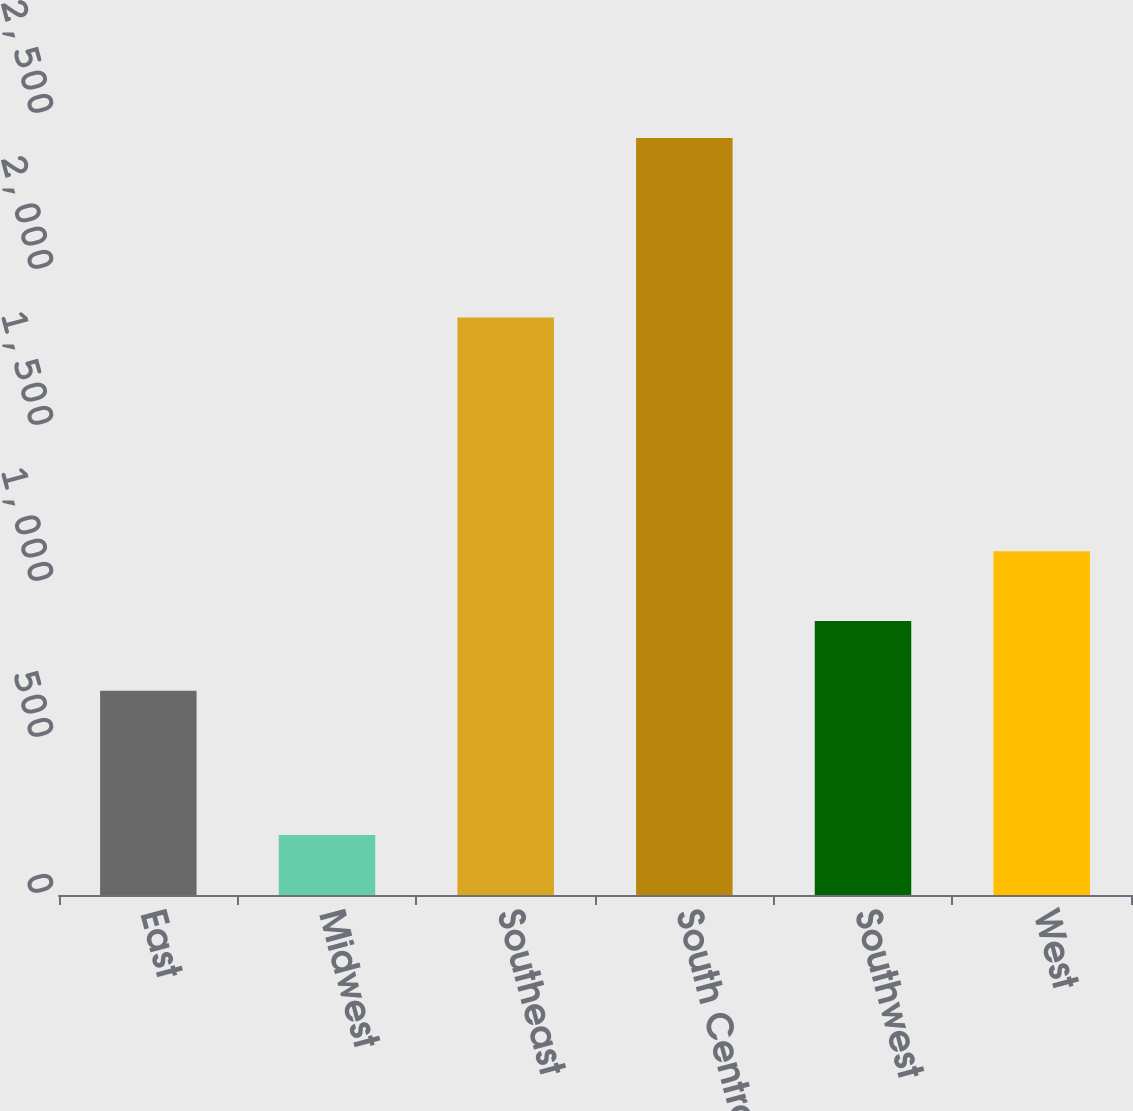Convert chart to OTSL. <chart><loc_0><loc_0><loc_500><loc_500><bar_chart><fcel>East<fcel>Midwest<fcel>Southeast<fcel>South Central<fcel>Southwest<fcel>West<nl><fcel>655<fcel>192<fcel>1851<fcel>2426<fcel>878.4<fcel>1101.8<nl></chart> 